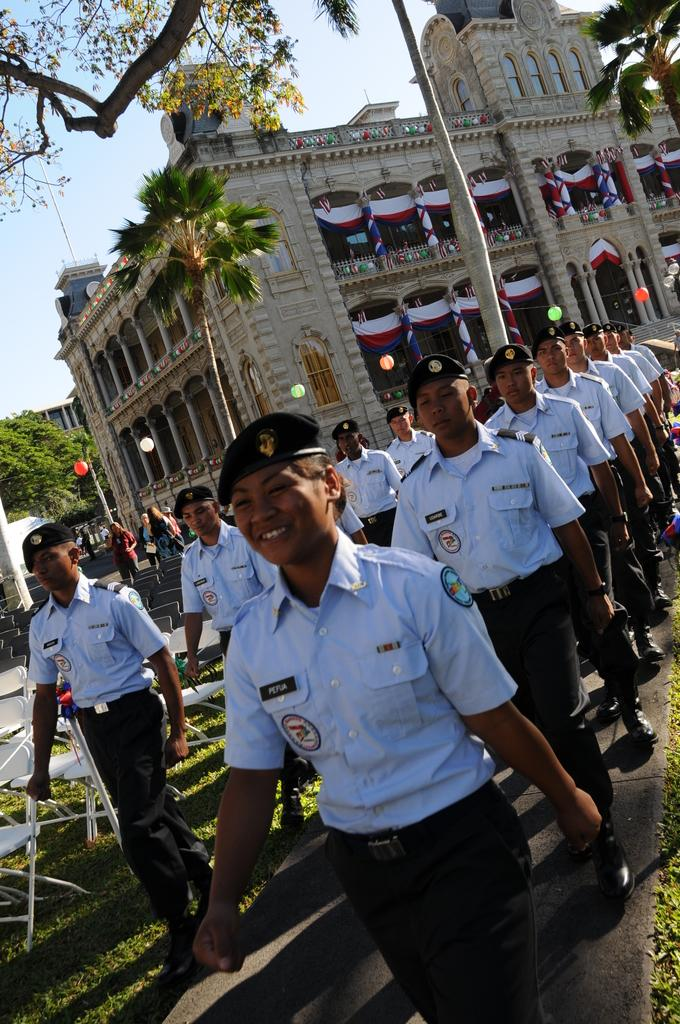Who or what is present in the image? There are people in the image. What can be seen in the distance behind the people? There are trees, buildings, and the sky visible in the background of the image. What type of scarecrow is standing near the border in the image? There is no scarecrow or border present in the image. What is the thing that the people are interacting with in the image? The provided facts do not mention any specific object or thing that the people are interacting with. 